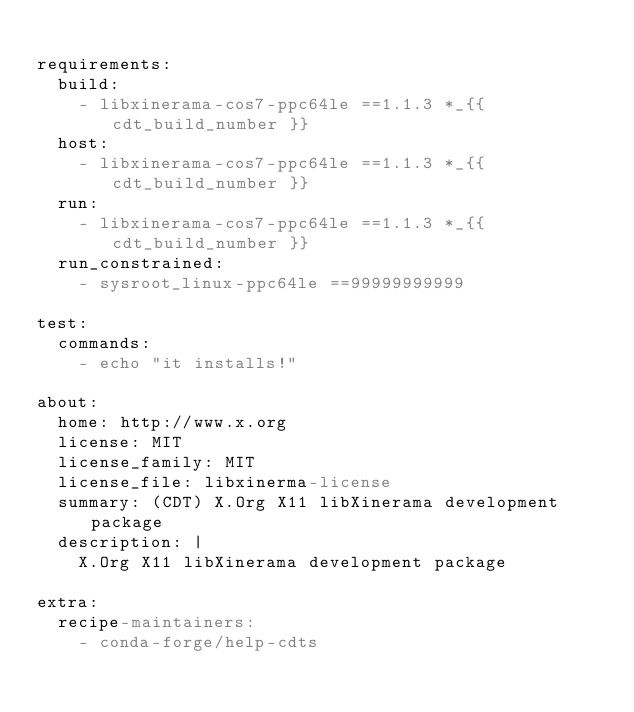<code> <loc_0><loc_0><loc_500><loc_500><_YAML_>
requirements:
  build:
    - libxinerama-cos7-ppc64le ==1.1.3 *_{{ cdt_build_number }}
  host:
    - libxinerama-cos7-ppc64le ==1.1.3 *_{{ cdt_build_number }}
  run:
    - libxinerama-cos7-ppc64le ==1.1.3 *_{{ cdt_build_number }}
  run_constrained:
    - sysroot_linux-ppc64le ==99999999999

test:
  commands:
    - echo "it installs!"

about:
  home: http://www.x.org
  license: MIT
  license_family: MIT
  license_file: libxinerma-license
  summary: (CDT) X.Org X11 libXinerama development package
  description: |
    X.Org X11 libXinerama development package

extra:
  recipe-maintainers:
    - conda-forge/help-cdts
</code> 